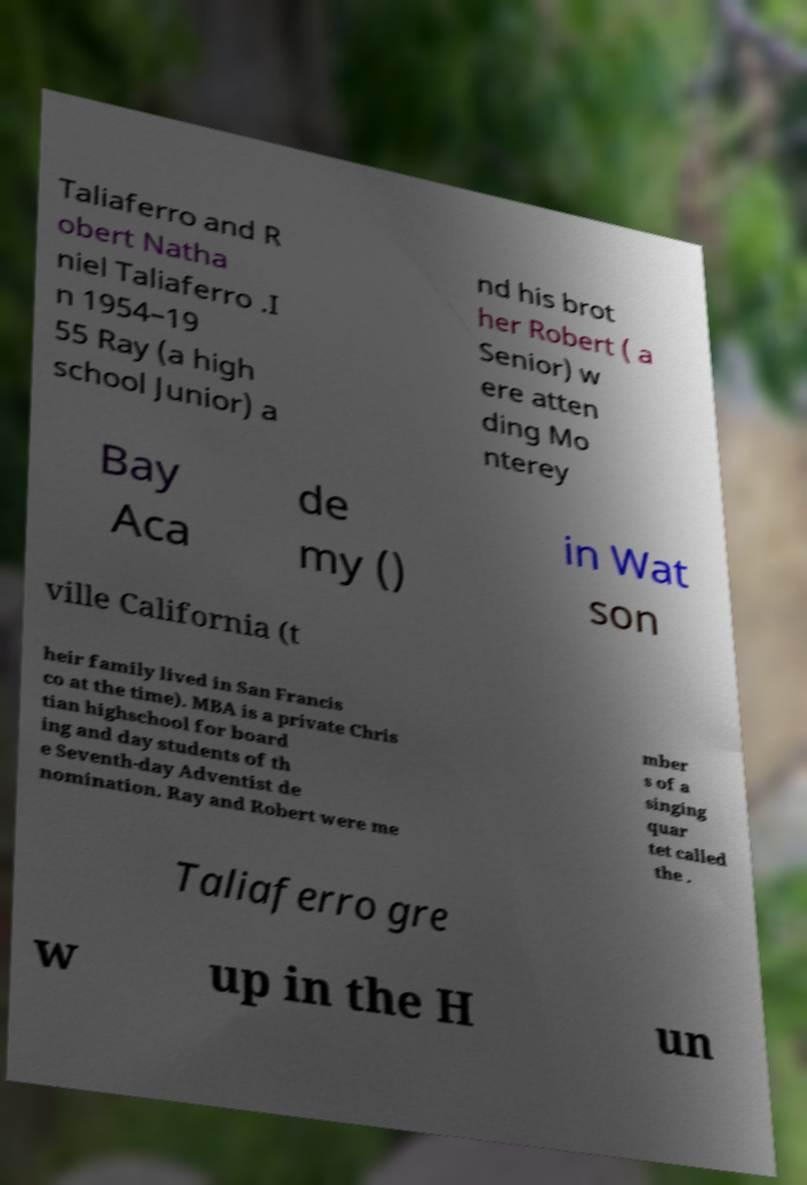Please read and relay the text visible in this image. What does it say? Taliaferro and R obert Natha niel Taliaferro .I n 1954–19 55 Ray (a high school Junior) a nd his brot her Robert ( a Senior) w ere atten ding Mo nterey Bay Aca de my () in Wat son ville California (t heir family lived in San Francis co at the time). MBA is a private Chris tian highschool for board ing and day students of th e Seventh-day Adventist de nomination. Ray and Robert were me mber s of a singing quar tet called the . Taliaferro gre w up in the H un 